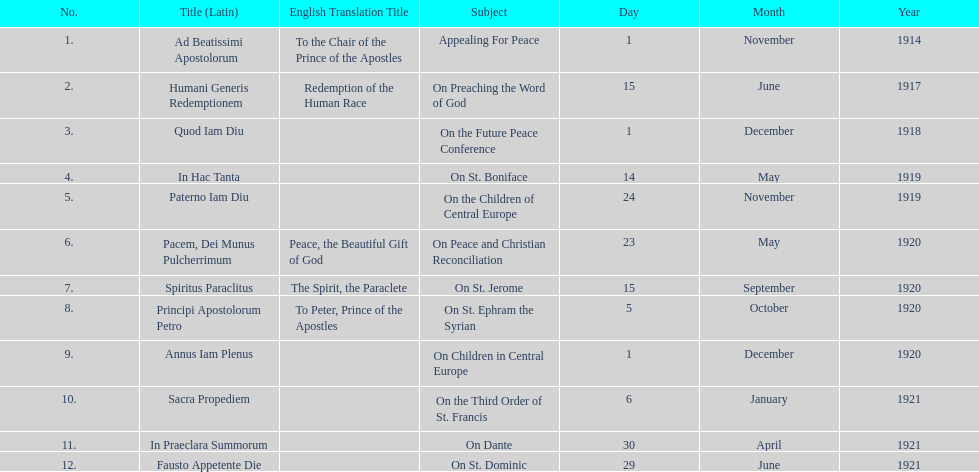What is the next title listed after sacra propediem? In Praeclara Summorum. 